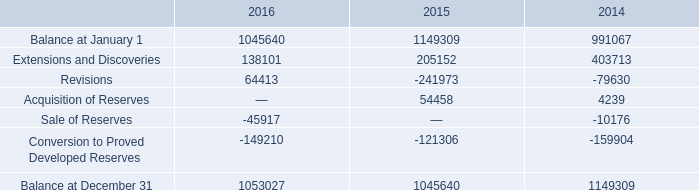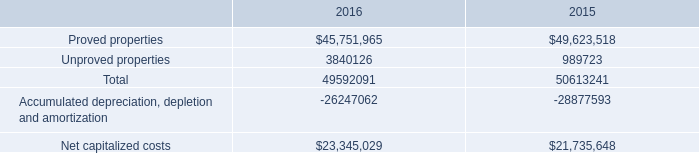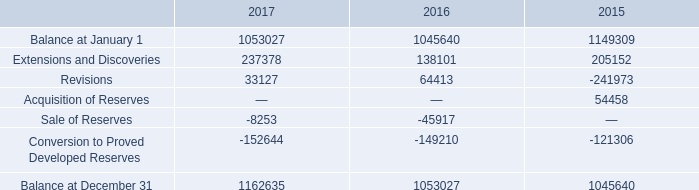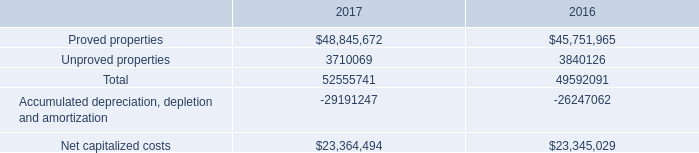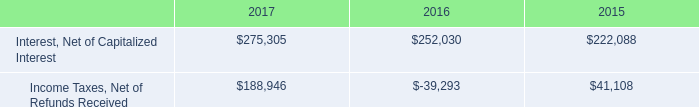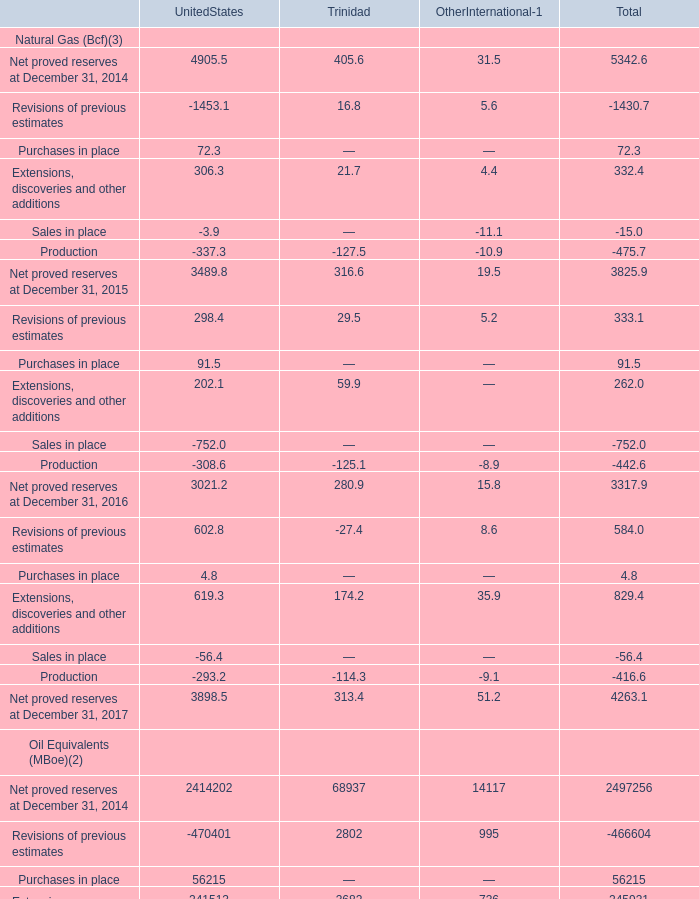What is the total amount of Extensions and Discoveries of 2015, Sale of Reserves of 2014, and Revisions of 2016 ? 
Computations: ((205152.0 + 10176.0) + 64413.0)
Answer: 279741.0. 